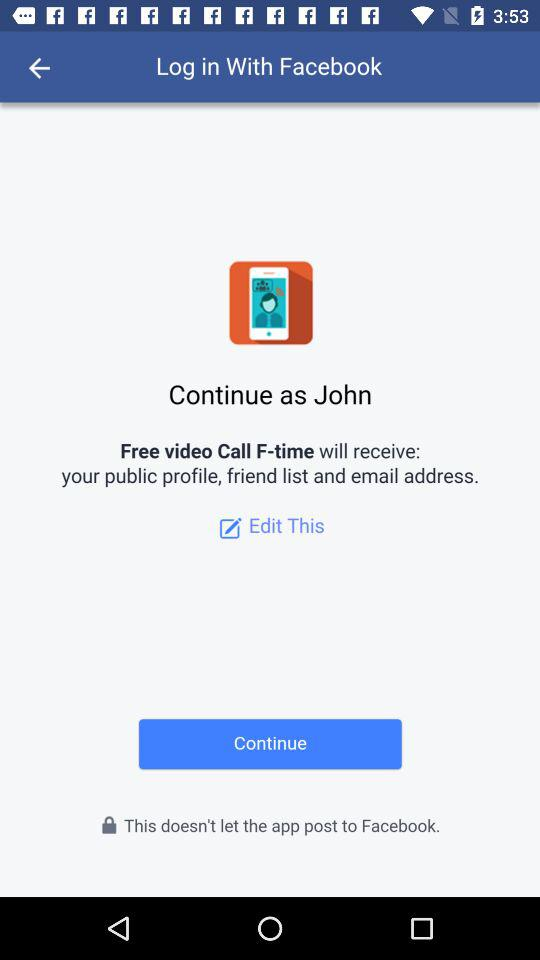Through what application can we log in? You can log in through "Facebook". 